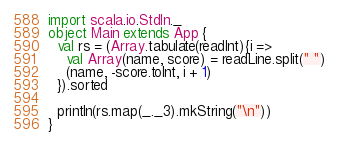<code> <loc_0><loc_0><loc_500><loc_500><_Scala_>import scala.io.StdIn._
object Main extends App {
  val rs = (Array.tabulate(readInt){i =>
    val Array(name, score) = readLine.split(" ")
    (name, -score.toInt, i + 1)
  }).sorted

  println(rs.map(_._3).mkString("\n"))
}</code> 